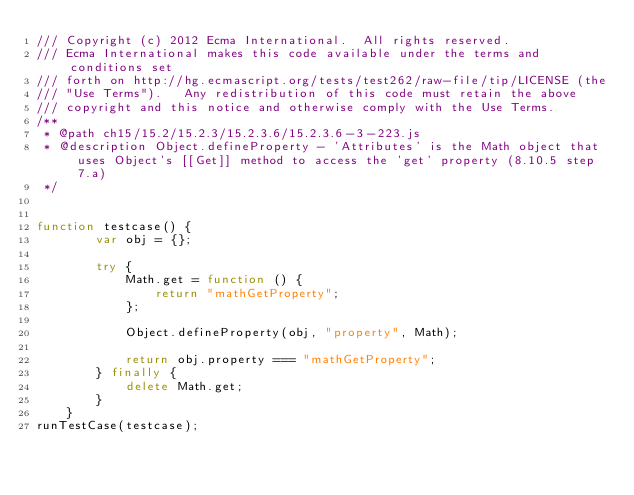Convert code to text. <code><loc_0><loc_0><loc_500><loc_500><_JavaScript_>/// Copyright (c) 2012 Ecma International.  All rights reserved. 
/// Ecma International makes this code available under the terms and conditions set
/// forth on http://hg.ecmascript.org/tests/test262/raw-file/tip/LICENSE (the 
/// "Use Terms").   Any redistribution of this code must retain the above 
/// copyright and this notice and otherwise comply with the Use Terms.
/**
 * @path ch15/15.2/15.2.3/15.2.3.6/15.2.3.6-3-223.js
 * @description Object.defineProperty - 'Attributes' is the Math object that uses Object's [[Get]] method to access the 'get' property (8.10.5 step 7.a)
 */


function testcase() {
        var obj = {};

        try {
            Math.get = function () {
                return "mathGetProperty";
            };

            Object.defineProperty(obj, "property", Math);

            return obj.property === "mathGetProperty";
        } finally {
            delete Math.get;
        }
    }
runTestCase(testcase);
</code> 